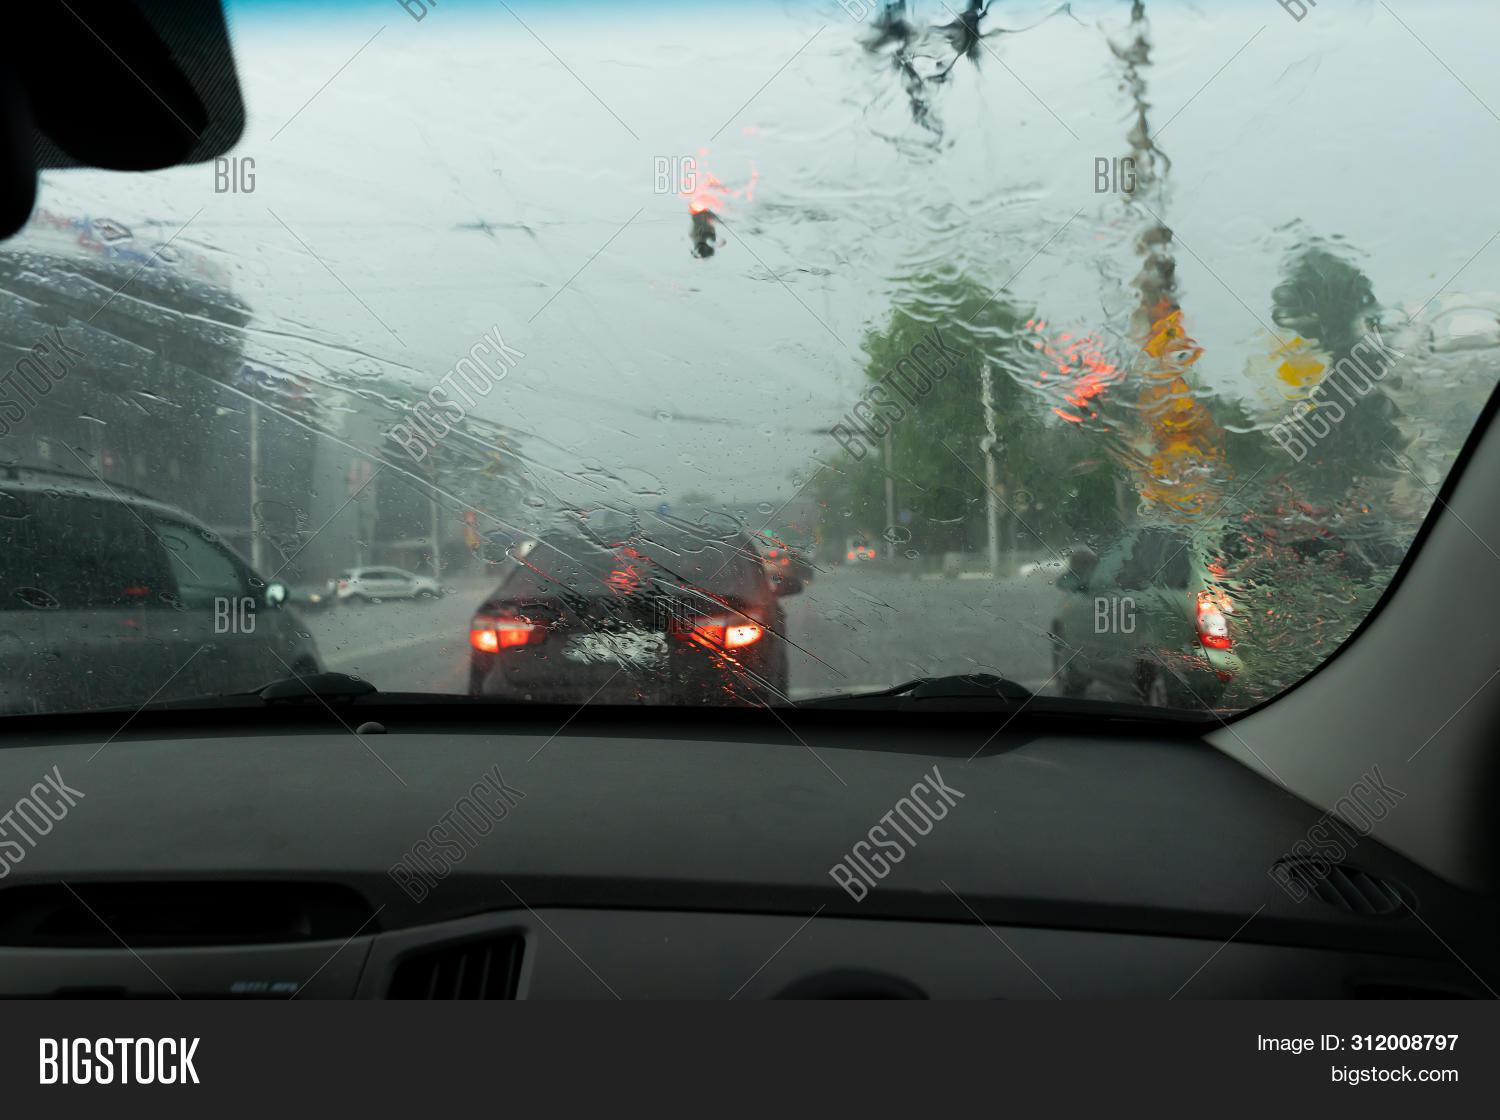Given the conditions, what precautions should the driver be taking? Under such wet and potentially slick road conditions, it's important for the driver to maintain a safe following distance from the car ahead, drive at reduced speeds to prevent hydroplaning, use their headlights to increase visibility, and ensure the windshield wipers are effectively clearing the rain from the windshield. 